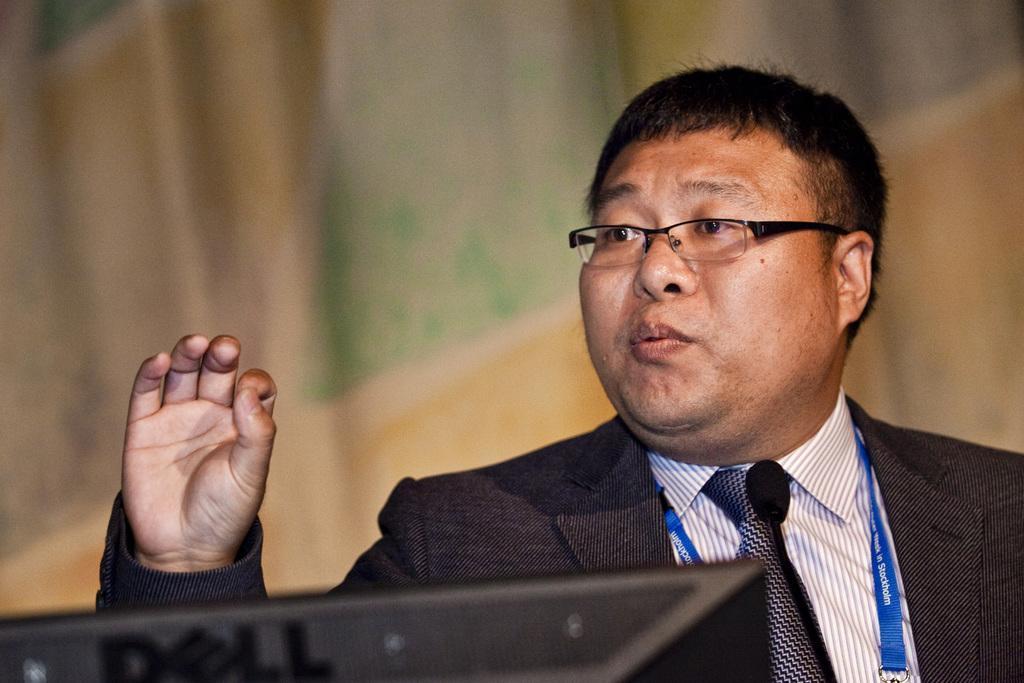Describe this image in one or two sentences. In this image we can see a man and at the bottom there is an object. In the background the image is blur but we can see an object. 